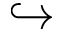<formula> <loc_0><loc_0><loc_500><loc_500>\hookrightarrow</formula> 